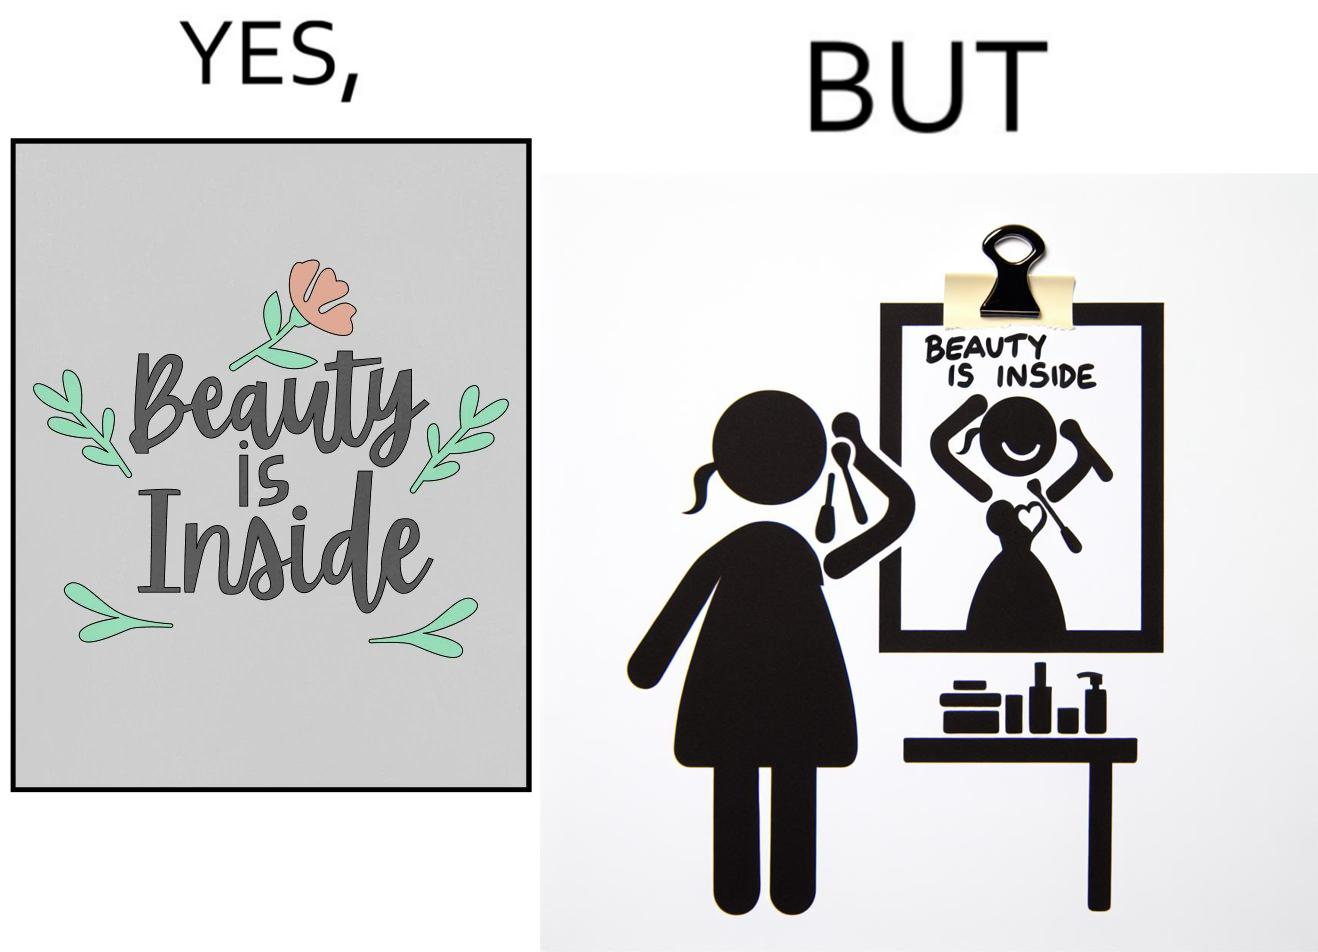Is this image satirical or non-satirical? Yes, this image is satirical. 